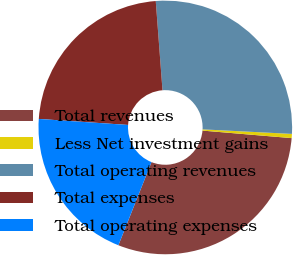Convert chart to OTSL. <chart><loc_0><loc_0><loc_500><loc_500><pie_chart><fcel>Total revenues<fcel>Less Net investment gains<fcel>Total operating revenues<fcel>Total expenses<fcel>Total operating expenses<nl><fcel>29.69%<fcel>0.53%<fcel>27.01%<fcel>22.73%<fcel>20.04%<nl></chart> 